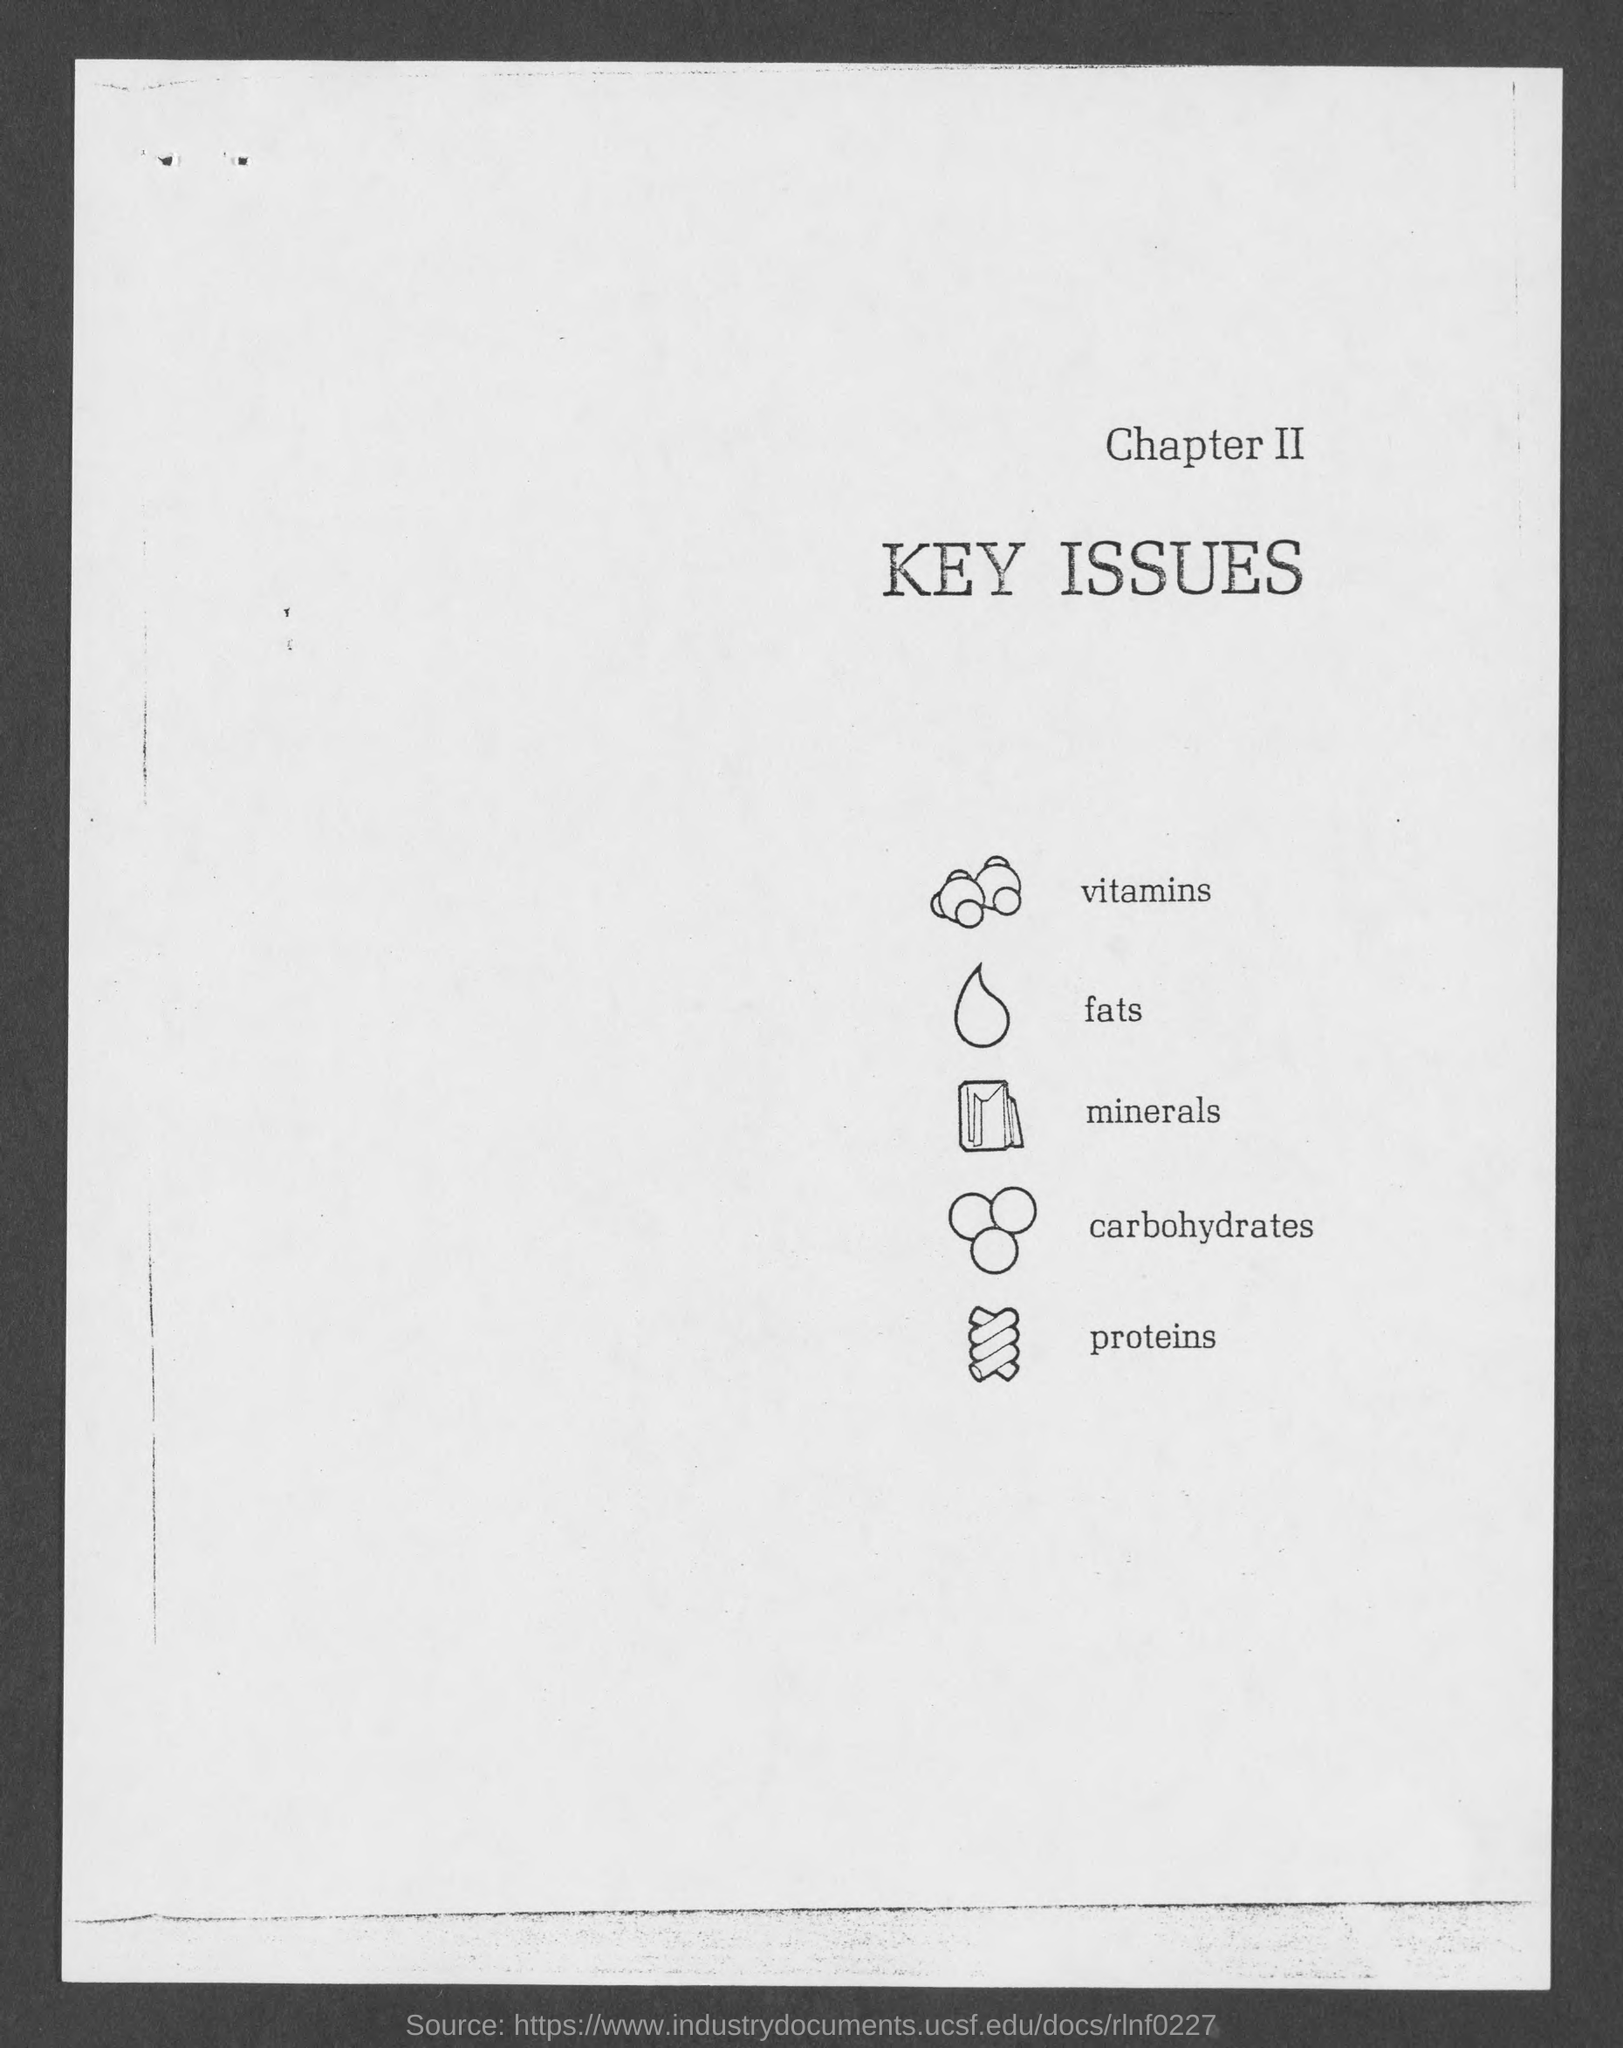What does Chapter II deal with?
Your answer should be compact. Key Issues. 